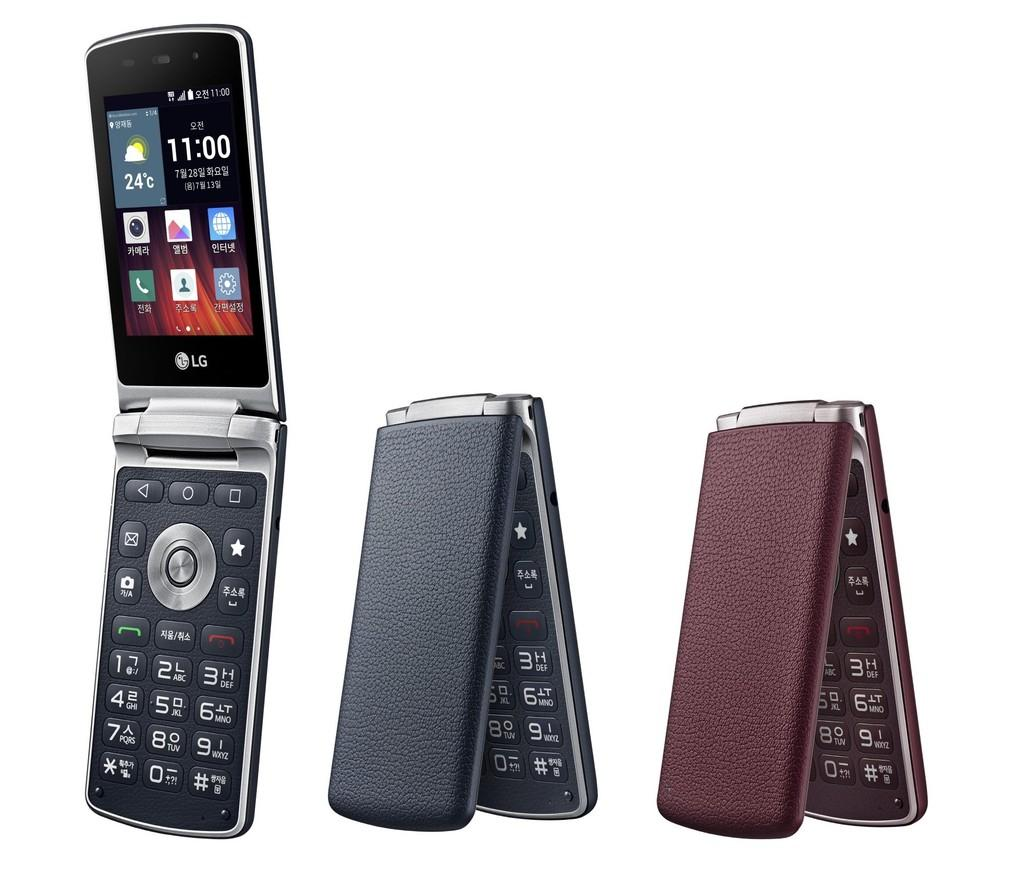<image>
Render a clear and concise summary of the photo. Cellphone by LG with the time set at 11:00. 